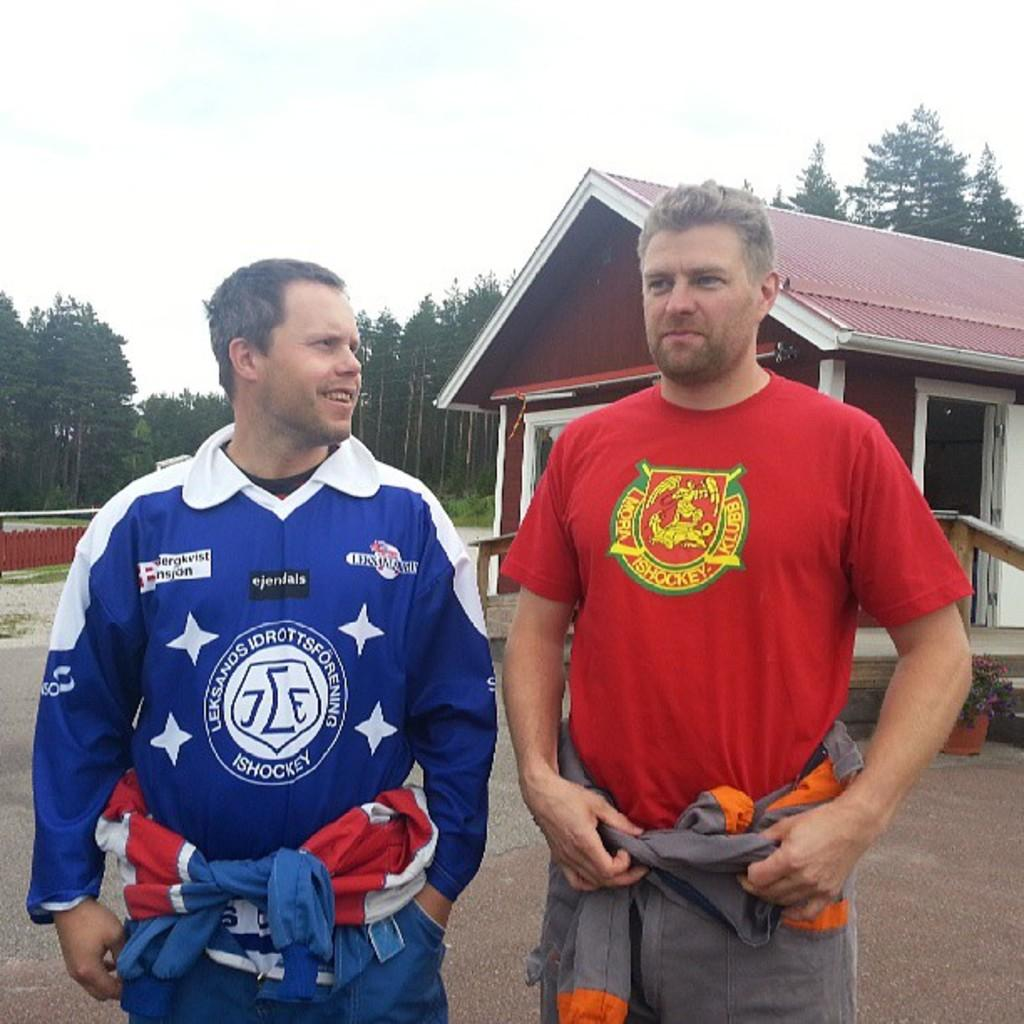<image>
Present a compact description of the photo's key features. Two men are standing by a forest and one has a red shirt that says Ishockey. 